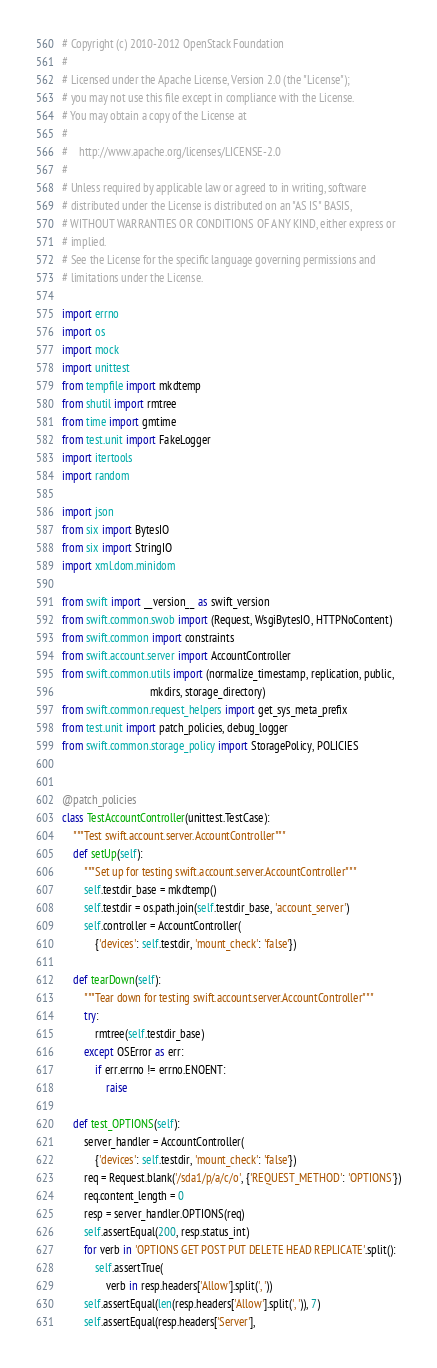<code> <loc_0><loc_0><loc_500><loc_500><_Python_># Copyright (c) 2010-2012 OpenStack Foundation
#
# Licensed under the Apache License, Version 2.0 (the "License");
# you may not use this file except in compliance with the License.
# You may obtain a copy of the License at
#
#    http://www.apache.org/licenses/LICENSE-2.0
#
# Unless required by applicable law or agreed to in writing, software
# distributed under the License is distributed on an "AS IS" BASIS,
# WITHOUT WARRANTIES OR CONDITIONS OF ANY KIND, either express or
# implied.
# See the License for the specific language governing permissions and
# limitations under the License.

import errno
import os
import mock
import unittest
from tempfile import mkdtemp
from shutil import rmtree
from time import gmtime
from test.unit import FakeLogger
import itertools
import random

import json
from six import BytesIO
from six import StringIO
import xml.dom.minidom

from swift import __version__ as swift_version
from swift.common.swob import (Request, WsgiBytesIO, HTTPNoContent)
from swift.common import constraints
from swift.account.server import AccountController
from swift.common.utils import (normalize_timestamp, replication, public,
                                mkdirs, storage_directory)
from swift.common.request_helpers import get_sys_meta_prefix
from test.unit import patch_policies, debug_logger
from swift.common.storage_policy import StoragePolicy, POLICIES


@patch_policies
class TestAccountController(unittest.TestCase):
    """Test swift.account.server.AccountController"""
    def setUp(self):
        """Set up for testing swift.account.server.AccountController"""
        self.testdir_base = mkdtemp()
        self.testdir = os.path.join(self.testdir_base, 'account_server')
        self.controller = AccountController(
            {'devices': self.testdir, 'mount_check': 'false'})

    def tearDown(self):
        """Tear down for testing swift.account.server.AccountController"""
        try:
            rmtree(self.testdir_base)
        except OSError as err:
            if err.errno != errno.ENOENT:
                raise

    def test_OPTIONS(self):
        server_handler = AccountController(
            {'devices': self.testdir, 'mount_check': 'false'})
        req = Request.blank('/sda1/p/a/c/o', {'REQUEST_METHOD': 'OPTIONS'})
        req.content_length = 0
        resp = server_handler.OPTIONS(req)
        self.assertEqual(200, resp.status_int)
        for verb in 'OPTIONS GET POST PUT DELETE HEAD REPLICATE'.split():
            self.assertTrue(
                verb in resp.headers['Allow'].split(', '))
        self.assertEqual(len(resp.headers['Allow'].split(', ')), 7)
        self.assertEqual(resp.headers['Server'],</code> 